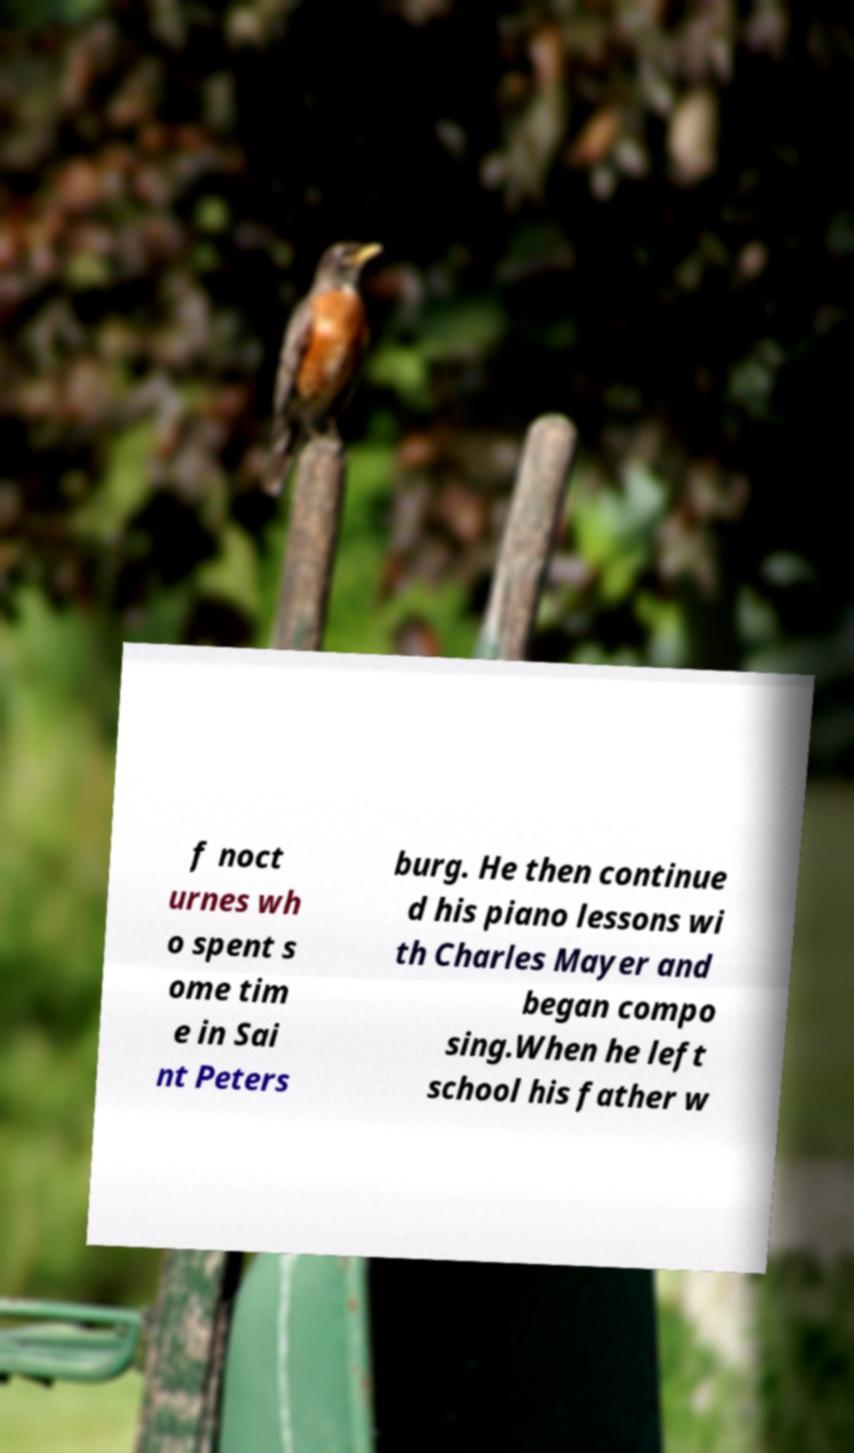I need the written content from this picture converted into text. Can you do that? f noct urnes wh o spent s ome tim e in Sai nt Peters burg. He then continue d his piano lessons wi th Charles Mayer and began compo sing.When he left school his father w 